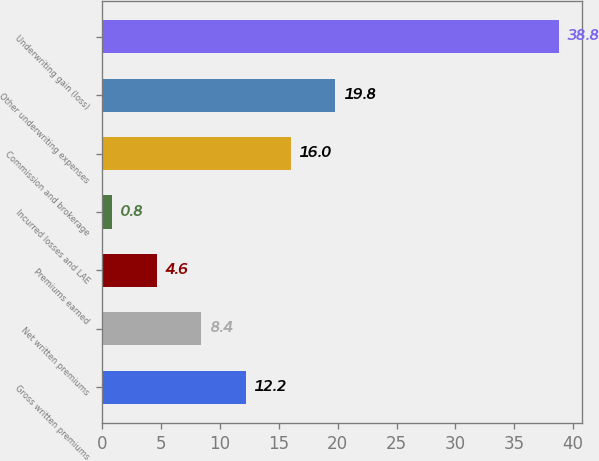Convert chart. <chart><loc_0><loc_0><loc_500><loc_500><bar_chart><fcel>Gross written premiums<fcel>Net written premiums<fcel>Premiums earned<fcel>Incurred losses and LAE<fcel>Commission and brokerage<fcel>Other underwriting expenses<fcel>Underwriting gain (loss)<nl><fcel>12.2<fcel>8.4<fcel>4.6<fcel>0.8<fcel>16<fcel>19.8<fcel>38.8<nl></chart> 